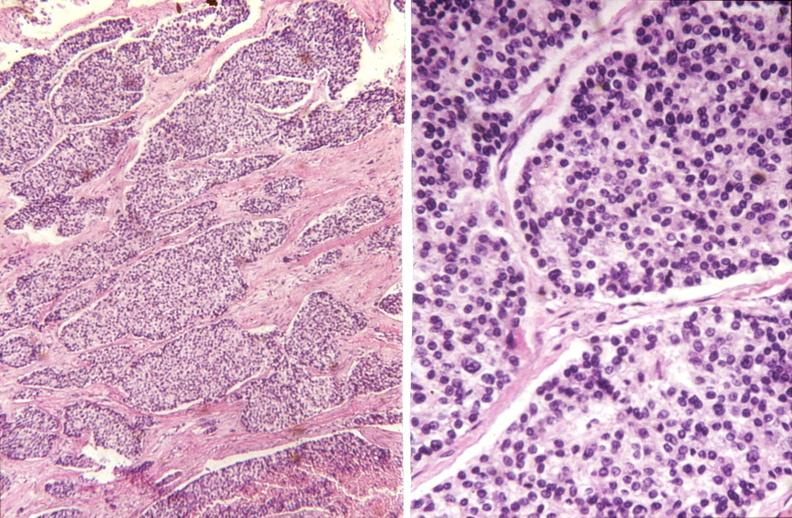what does this image show?
Answer the question using a single word or phrase. Parathyroid 